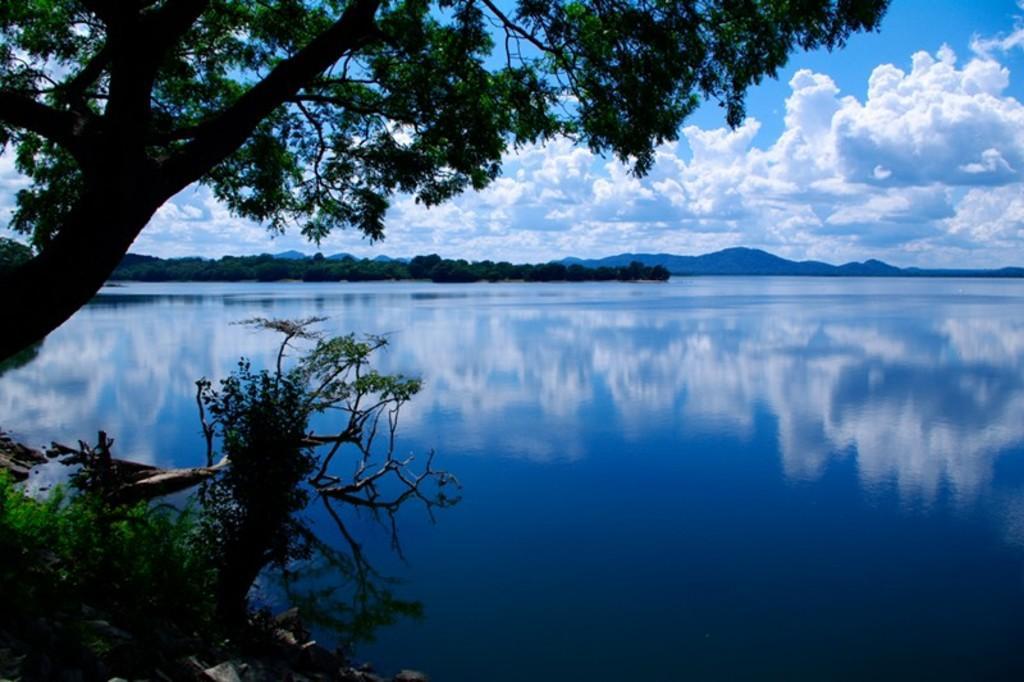Please provide a concise description of this image. In the image we can see there is water and there are trees. There is a cloudy sky. 